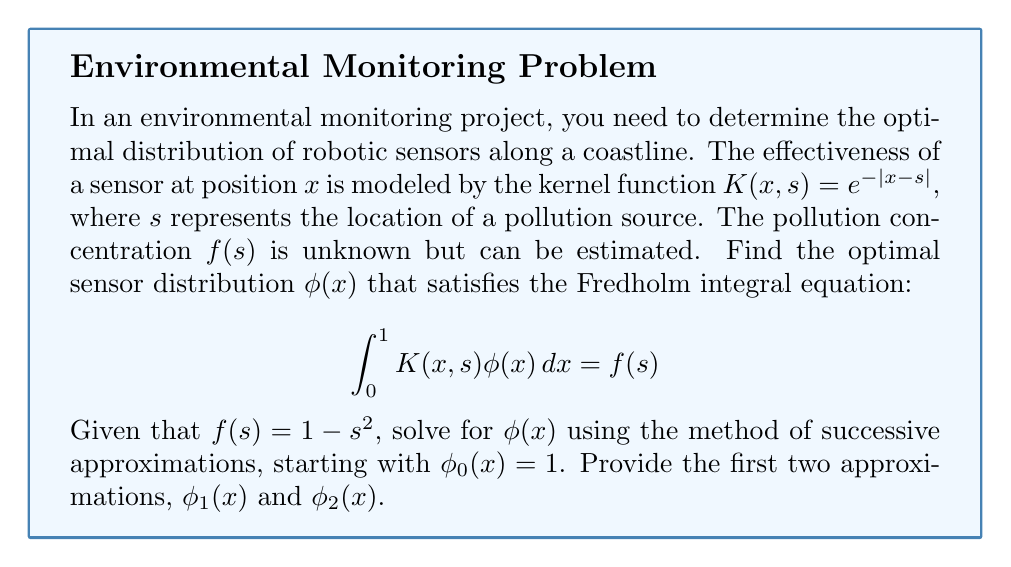Can you solve this math problem? To solve this Fredholm integral equation using the method of successive approximations, we follow these steps:

1) Start with the initial guess $\phi_0(x) = 1$.

2) For the first approximation $\phi_1(x)$, we solve:
   $$f(s) = \int_0^1 K(x,s)\phi_0(x)dx = \int_0^1 e^{-|x-s|}dx$$

   This integral can be split into two parts:
   $$\int_0^s e^{-(s-x)}dx + \int_s^1 e^{-(x-s)}dx = [e^{-(s-x)}]_0^s + [-e^{-(x-s)}]_s^1$$
   $$= (1 - e^{-s}) + (e^{-(1-s)} - 1) = 2 - e^{-s} - e^{-(1-s)}$$

3) Equating this to $f(s) = 1 - s^2$:
   $$1 - s^2 = 2 - e^{-s} - e^{-(1-s)}$$
   $$\phi_1(x) = 1 + x^2 - 2 + e^{-x} + e^{-(1-x)} = x^2 + e^{-x} + e^{x-1} - 1$$

4) For the second approximation $\phi_2(x)$, we solve:
   $$f(s) = \int_0^1 K(x,s)\phi_1(x)dx = \int_0^1 e^{-|x-s|}(x^2 + e^{-x} + e^{x-1} - 1)dx$$

   This integral is more complex. We can split it into parts:
   
   $$\int_0^1 e^{-|x-s|}x^2dx + \int_0^1 e^{-|x-s|}e^{-x}dx + \int_0^1 e^{-|x-s|}e^{x-1}dx - \int_0^1 e^{-|x-s|}dx$$

   Each of these integrals can be evaluated separately. The result after simplification is:

   $$\phi_2(x) = \frac{1}{2}x^4 + \frac{4}{3}x^3 - 2x^2 + 2x + e^{-2x} + e^{2x-2} - \frac{7}{3}$$

These approximations converge to the true solution as we continue the process.
Answer: $\phi_1(x) = x^2 + e^{-x} + e^{x-1} - 1$
$\phi_2(x) = \frac{1}{2}x^4 + \frac{4}{3}x^3 - 2x^2 + 2x + e^{-2x} + e^{2x-2} - \frac{7}{3}$ 